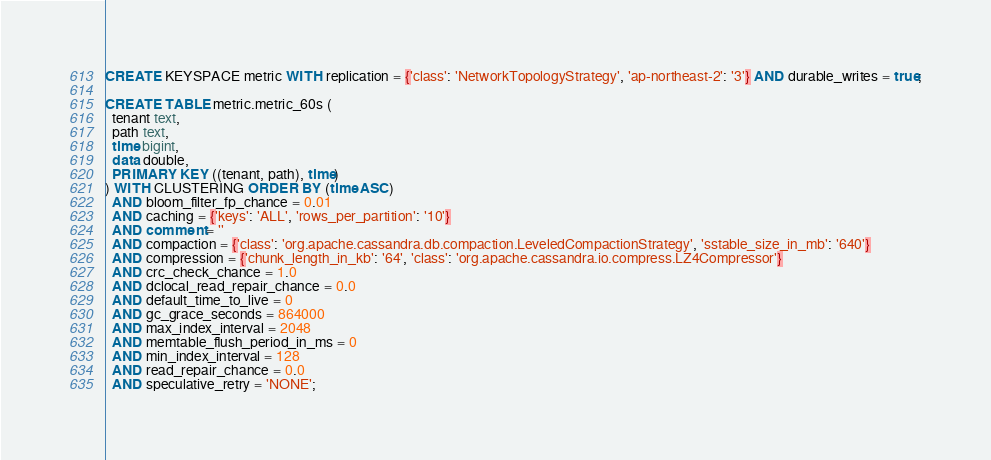<code> <loc_0><loc_0><loc_500><loc_500><_SQL_>CREATE KEYSPACE metric WITH replication = {'class': 'NetworkTopologyStrategy', 'ap-northeast-2': '3'} AND durable_writes = true;

CREATE TABLE metric.metric_60s (
  tenant text,
  path text,
  time bigint,
  data double,
  PRIMARY KEY ((tenant, path), time)
) WITH CLUSTERING ORDER BY (time ASC)
  AND bloom_filter_fp_chance = 0.01
  AND caching = {'keys': 'ALL', 'rows_per_partition': '10'}
  AND comment = ''
  AND compaction = {'class': 'org.apache.cassandra.db.compaction.LeveledCompactionStrategy', 'sstable_size_in_mb': '640'}
  AND compression = {'chunk_length_in_kb': '64', 'class': 'org.apache.cassandra.io.compress.LZ4Compressor'}
  AND crc_check_chance = 1.0
  AND dclocal_read_repair_chance = 0.0
  AND default_time_to_live = 0
  AND gc_grace_seconds = 864000
  AND max_index_interval = 2048
  AND memtable_flush_period_in_ms = 0
  AND min_index_interval = 128
  AND read_repair_chance = 0.0
  AND speculative_retry = 'NONE';
</code> 